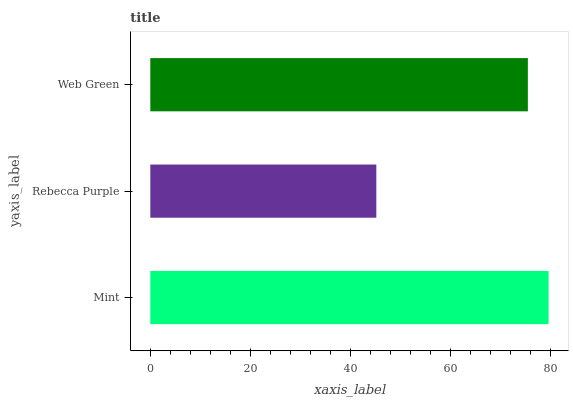Is Rebecca Purple the minimum?
Answer yes or no. Yes. Is Mint the maximum?
Answer yes or no. Yes. Is Web Green the minimum?
Answer yes or no. No. Is Web Green the maximum?
Answer yes or no. No. Is Web Green greater than Rebecca Purple?
Answer yes or no. Yes. Is Rebecca Purple less than Web Green?
Answer yes or no. Yes. Is Rebecca Purple greater than Web Green?
Answer yes or no. No. Is Web Green less than Rebecca Purple?
Answer yes or no. No. Is Web Green the high median?
Answer yes or no. Yes. Is Web Green the low median?
Answer yes or no. Yes. Is Mint the high median?
Answer yes or no. No. Is Mint the low median?
Answer yes or no. No. 